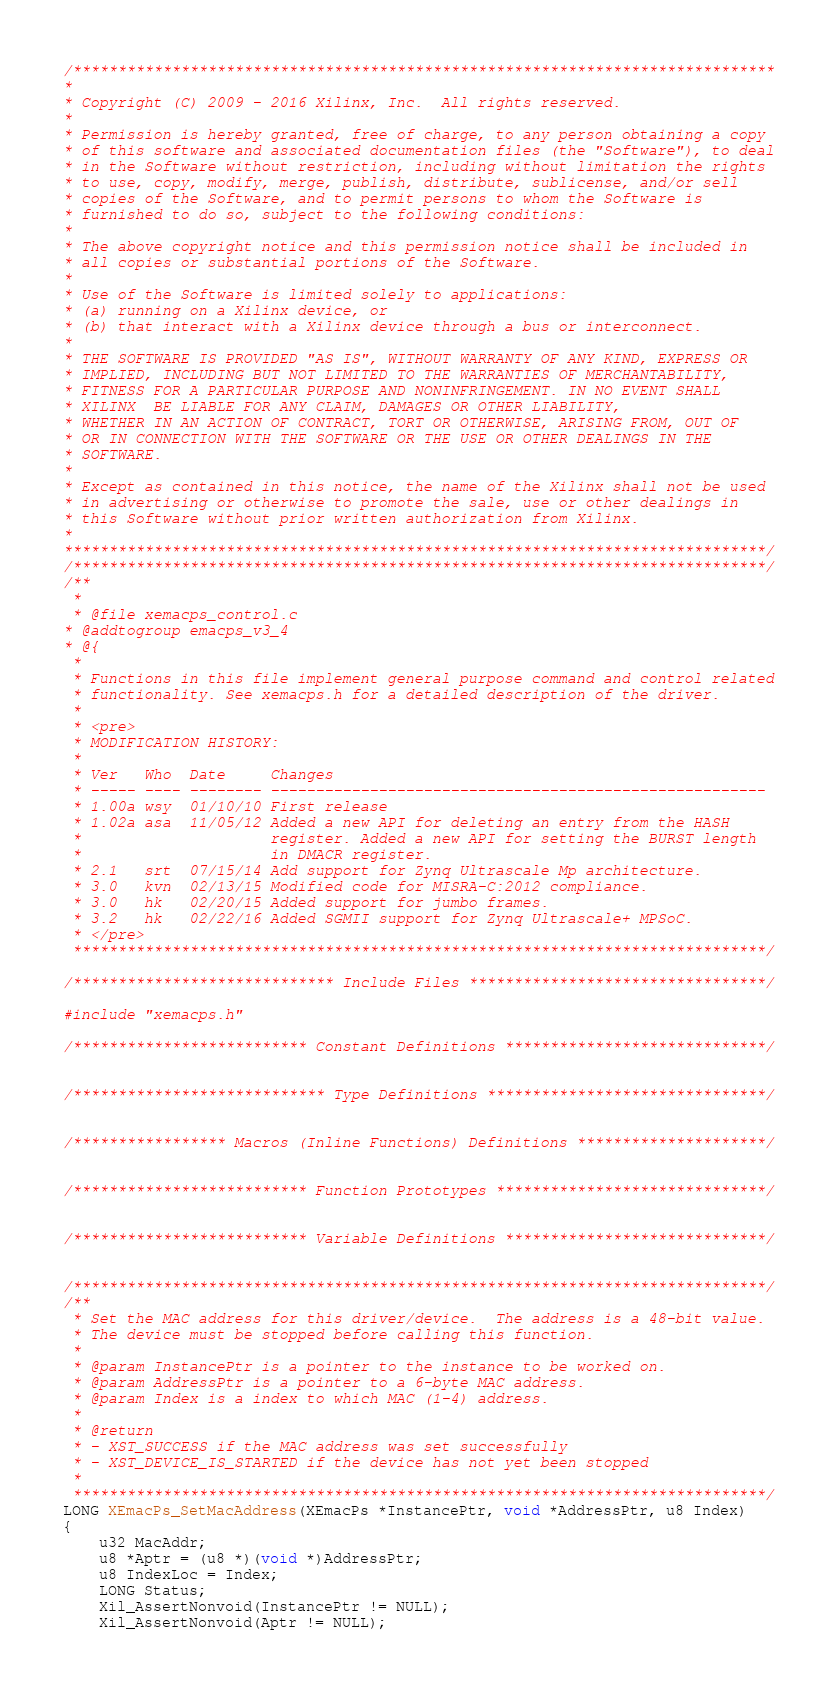<code> <loc_0><loc_0><loc_500><loc_500><_C_>/******************************************************************************
*
* Copyright (C) 2009 - 2016 Xilinx, Inc.  All rights reserved.
*
* Permission is hereby granted, free of charge, to any person obtaining a copy
* of this software and associated documentation files (the "Software"), to deal
* in the Software without restriction, including without limitation the rights
* to use, copy, modify, merge, publish, distribute, sublicense, and/or sell
* copies of the Software, and to permit persons to whom the Software is
* furnished to do so, subject to the following conditions:
*
* The above copyright notice and this permission notice shall be included in
* all copies or substantial portions of the Software.
*
* Use of the Software is limited solely to applications:
* (a) running on a Xilinx device, or
* (b) that interact with a Xilinx device through a bus or interconnect.
*
* THE SOFTWARE IS PROVIDED "AS IS", WITHOUT WARRANTY OF ANY KIND, EXPRESS OR
* IMPLIED, INCLUDING BUT NOT LIMITED TO THE WARRANTIES OF MERCHANTABILITY,
* FITNESS FOR A PARTICULAR PURPOSE AND NONINFRINGEMENT. IN NO EVENT SHALL
* XILINX  BE LIABLE FOR ANY CLAIM, DAMAGES OR OTHER LIABILITY,
* WHETHER IN AN ACTION OF CONTRACT, TORT OR OTHERWISE, ARISING FROM, OUT OF
* OR IN CONNECTION WITH THE SOFTWARE OR THE USE OR OTHER DEALINGS IN THE
* SOFTWARE.
*
* Except as contained in this notice, the name of the Xilinx shall not be used
* in advertising or otherwise to promote the sale, use or other dealings in
* this Software without prior written authorization from Xilinx.
*
******************************************************************************/
/*****************************************************************************/
/**
 *
 * @file xemacps_control.c
* @addtogroup emacps_v3_4
* @{
 *
 * Functions in this file implement general purpose command and control related
 * functionality. See xemacps.h for a detailed description of the driver.
 *
 * <pre>
 * MODIFICATION HISTORY:
 *
 * Ver   Who  Date     Changes
 * ----- ---- -------- -------------------------------------------------------
 * 1.00a wsy  01/10/10 First release
 * 1.02a asa  11/05/12 Added a new API for deleting an entry from the HASH
 *					   register. Added a new API for setting the BURST length
 *					   in DMACR register.
 * 2.1   srt  07/15/14 Add support for Zynq Ultrascale Mp architecture.
 * 3.0   kvn  02/13/15 Modified code for MISRA-C:2012 compliance.
 * 3.0   hk   02/20/15 Added support for jumbo frames.
 * 3.2   hk   02/22/16 Added SGMII support for Zynq Ultrascale+ MPSoC.
 * </pre>
 *****************************************************************************/

/***************************** Include Files *********************************/

#include "xemacps.h"

/************************** Constant Definitions *****************************/


/**************************** Type Definitions *******************************/


/***************** Macros (Inline Functions) Definitions *********************/


/************************** Function Prototypes ******************************/


/************************** Variable Definitions *****************************/


/*****************************************************************************/
/**
 * Set the MAC address for this driver/device.  The address is a 48-bit value.
 * The device must be stopped before calling this function.
 *
 * @param InstancePtr is a pointer to the instance to be worked on.
 * @param AddressPtr is a pointer to a 6-byte MAC address.
 * @param Index is a index to which MAC (1-4) address.
 *
 * @return
 * - XST_SUCCESS if the MAC address was set successfully
 * - XST_DEVICE_IS_STARTED if the device has not yet been stopped
 *
 *****************************************************************************/
LONG XEmacPs_SetMacAddress(XEmacPs *InstancePtr, void *AddressPtr, u8 Index)
{
	u32 MacAddr;
	u8 *Aptr = (u8 *)(void *)AddressPtr;
	u8 IndexLoc = Index;
	LONG Status;
	Xil_AssertNonvoid(InstancePtr != NULL);
	Xil_AssertNonvoid(Aptr != NULL);</code> 